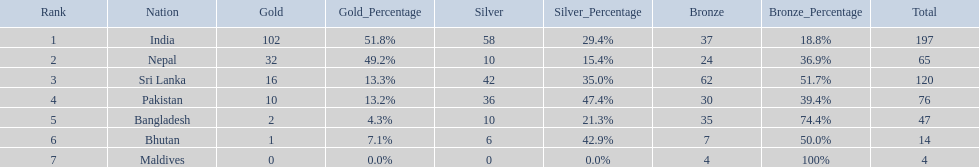Which nations played at the 1999 south asian games? India, Nepal, Sri Lanka, Pakistan, Bangladesh, Bhutan, Maldives. Which country is listed second in the table? Nepal. 